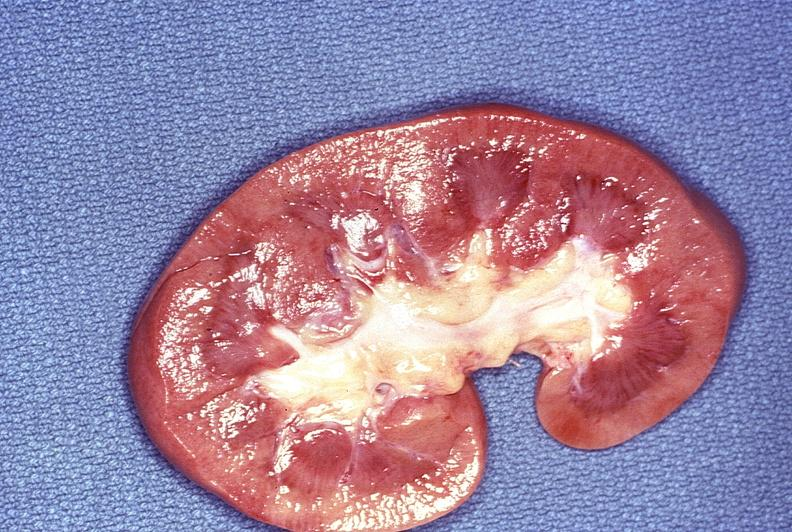what does this image show?
Answer the question using a single word or phrase. Normal kidney 